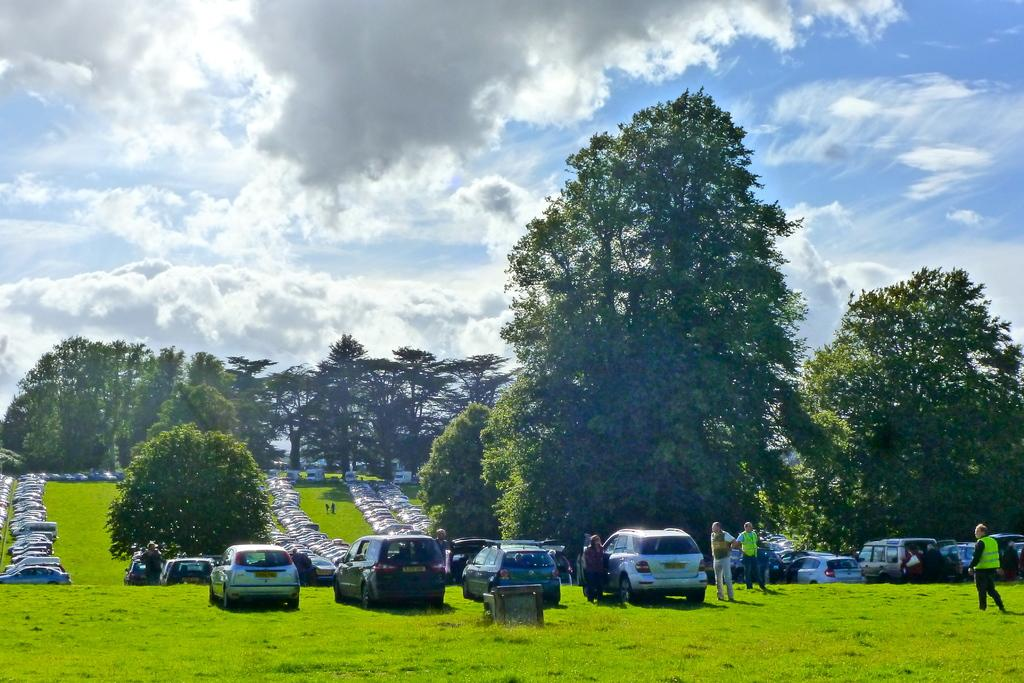What can be seen in the image in terms of vehicles? There are many cars parked in the image. What are the people in the image doing? The people in the image are standing on the grass. What type of vegetation is visible in the background of the image? There are many trees in the background of the image. What is visible in the sky in the image? The sky is visible in the background of the image, and clouds are present. What type of beast can be seen hiding under the cars in the image? There is no beast present in the image; it only shows cars parked and people standing on the grass. What color is the underwear of the person standing on the grass in the image? There is no information about the color of anyone's underwear in the image, as it is not visible. 